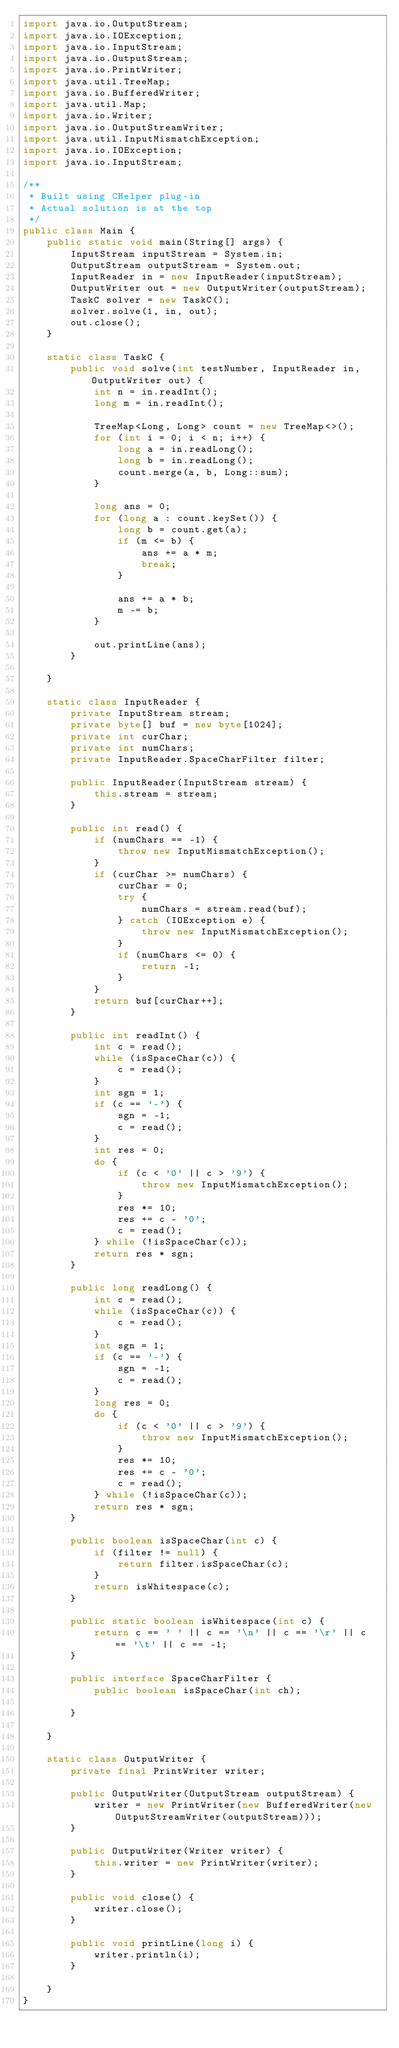<code> <loc_0><loc_0><loc_500><loc_500><_Java_>import java.io.OutputStream;
import java.io.IOException;
import java.io.InputStream;
import java.io.OutputStream;
import java.io.PrintWriter;
import java.util.TreeMap;
import java.io.BufferedWriter;
import java.util.Map;
import java.io.Writer;
import java.io.OutputStreamWriter;
import java.util.InputMismatchException;
import java.io.IOException;
import java.io.InputStream;

/**
 * Built using CHelper plug-in
 * Actual solution is at the top
 */
public class Main {
    public static void main(String[] args) {
        InputStream inputStream = System.in;
        OutputStream outputStream = System.out;
        InputReader in = new InputReader(inputStream);
        OutputWriter out = new OutputWriter(outputStream);
        TaskC solver = new TaskC();
        solver.solve(1, in, out);
        out.close();
    }

    static class TaskC {
        public void solve(int testNumber, InputReader in, OutputWriter out) {
            int n = in.readInt();
            long m = in.readInt();

            TreeMap<Long, Long> count = new TreeMap<>();
            for (int i = 0; i < n; i++) {
                long a = in.readLong();
                long b = in.readLong();
                count.merge(a, b, Long::sum);
            }

            long ans = 0;
            for (long a : count.keySet()) {
                long b = count.get(a);
                if (m <= b) {
                    ans += a * m;
                    break;
                }

                ans += a * b;
                m -= b;
            }

            out.printLine(ans);
        }

    }

    static class InputReader {
        private InputStream stream;
        private byte[] buf = new byte[1024];
        private int curChar;
        private int numChars;
        private InputReader.SpaceCharFilter filter;

        public InputReader(InputStream stream) {
            this.stream = stream;
        }

        public int read() {
            if (numChars == -1) {
                throw new InputMismatchException();
            }
            if (curChar >= numChars) {
                curChar = 0;
                try {
                    numChars = stream.read(buf);
                } catch (IOException e) {
                    throw new InputMismatchException();
                }
                if (numChars <= 0) {
                    return -1;
                }
            }
            return buf[curChar++];
        }

        public int readInt() {
            int c = read();
            while (isSpaceChar(c)) {
                c = read();
            }
            int sgn = 1;
            if (c == '-') {
                sgn = -1;
                c = read();
            }
            int res = 0;
            do {
                if (c < '0' || c > '9') {
                    throw new InputMismatchException();
                }
                res *= 10;
                res += c - '0';
                c = read();
            } while (!isSpaceChar(c));
            return res * sgn;
        }

        public long readLong() {
            int c = read();
            while (isSpaceChar(c)) {
                c = read();
            }
            int sgn = 1;
            if (c == '-') {
                sgn = -1;
                c = read();
            }
            long res = 0;
            do {
                if (c < '0' || c > '9') {
                    throw new InputMismatchException();
                }
                res *= 10;
                res += c - '0';
                c = read();
            } while (!isSpaceChar(c));
            return res * sgn;
        }

        public boolean isSpaceChar(int c) {
            if (filter != null) {
                return filter.isSpaceChar(c);
            }
            return isWhitespace(c);
        }

        public static boolean isWhitespace(int c) {
            return c == ' ' || c == '\n' || c == '\r' || c == '\t' || c == -1;
        }

        public interface SpaceCharFilter {
            public boolean isSpaceChar(int ch);

        }

    }

    static class OutputWriter {
        private final PrintWriter writer;

        public OutputWriter(OutputStream outputStream) {
            writer = new PrintWriter(new BufferedWriter(new OutputStreamWriter(outputStream)));
        }

        public OutputWriter(Writer writer) {
            this.writer = new PrintWriter(writer);
        }

        public void close() {
            writer.close();
        }

        public void printLine(long i) {
            writer.println(i);
        }

    }
}

</code> 